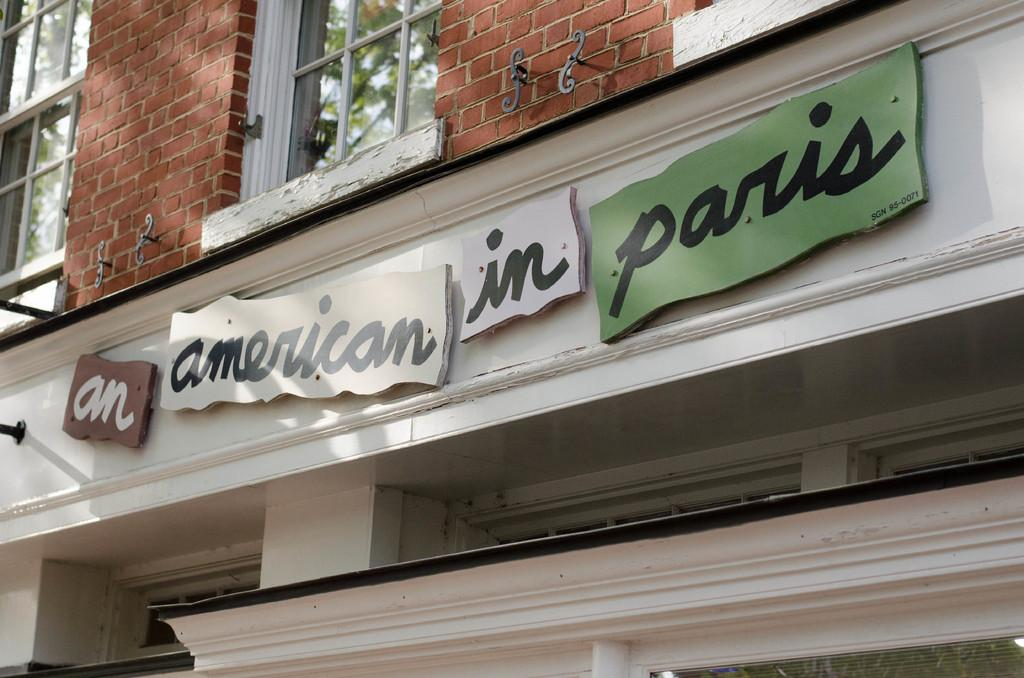What type of structure is present in the image? There is a building in the image. What can be seen on the building? There are boards with text on the building. What architectural feature is present on the building? There are windows on the building. What is visible through the windows? Trees are visible through the windows. What type of tooth is visible in the image? There is no tooth present in the image. How many trains can be seen passing by the building in the image? There are no trains visible in the image. 